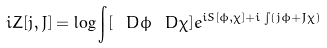<formula> <loc_0><loc_0><loc_500><loc_500>i Z [ j , J ] = \log \int [ \ D \phi \ D \chi ] e ^ { i S [ \phi , \chi ] + i \int ( j \phi + J \chi ) }</formula> 